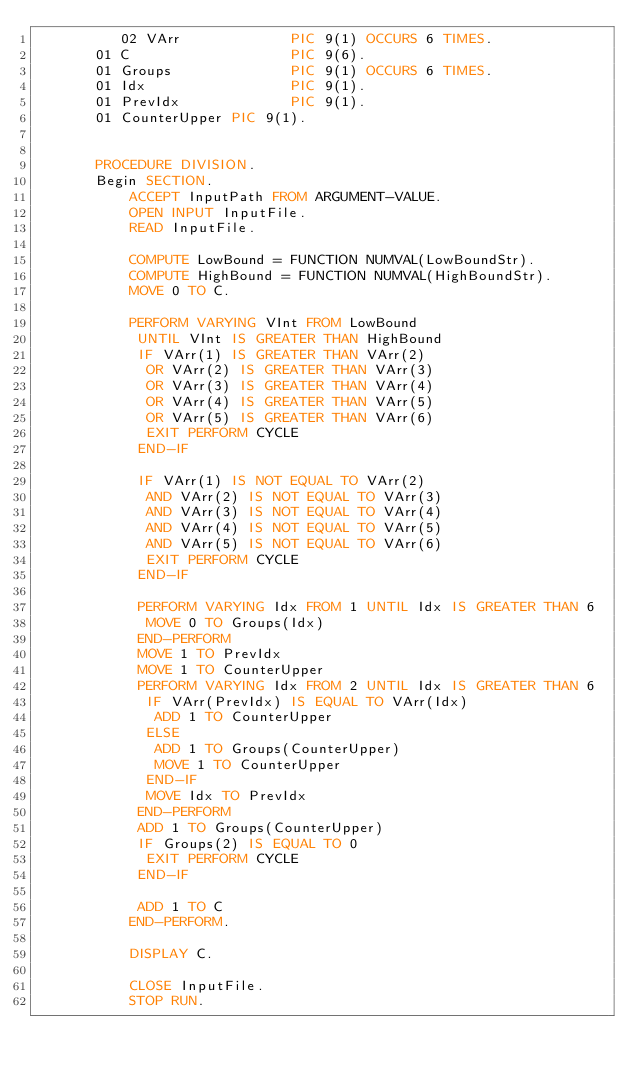<code> <loc_0><loc_0><loc_500><loc_500><_COBOL_>          02 VArr             PIC 9(1) OCCURS 6 TIMES.
       01 C                   PIC 9(6).
       01 Groups              PIC 9(1) OCCURS 6 TIMES.
       01 Idx                 PIC 9(1).
       01 PrevIdx             PIC 9(1).
       01 CounterUpper PIC 9(1).


       PROCEDURE DIVISION.
       Begin SECTION.
           ACCEPT InputPath FROM ARGUMENT-VALUE.
           OPEN INPUT InputFile.
           READ InputFile.

           COMPUTE LowBound = FUNCTION NUMVAL(LowBoundStr).
           COMPUTE HighBound = FUNCTION NUMVAL(HighBoundStr).
           MOVE 0 TO C.

           PERFORM VARYING VInt FROM LowBound 
            UNTIL VInt IS GREATER THAN HighBound
            IF VArr(1) IS GREATER THAN VArr(2)
             OR VArr(2) IS GREATER THAN VArr(3)
             OR VArr(3) IS GREATER THAN VArr(4)
             OR VArr(4) IS GREATER THAN VArr(5)
             OR VArr(5) IS GREATER THAN VArr(6)
             EXIT PERFORM CYCLE
            END-IF

            IF VArr(1) IS NOT EQUAL TO VArr(2)
             AND VArr(2) IS NOT EQUAL TO VArr(3)
             AND VArr(3) IS NOT EQUAL TO VArr(4)
             AND VArr(4) IS NOT EQUAL TO VArr(5)
             AND VArr(5) IS NOT EQUAL TO VArr(6)
             EXIT PERFORM CYCLE
            END-IF

            PERFORM VARYING Idx FROM 1 UNTIL Idx IS GREATER THAN 6
             MOVE 0 TO Groups(Idx)
            END-PERFORM
            MOVE 1 TO PrevIdx
            MOVE 1 TO CounterUpper
            PERFORM VARYING Idx FROM 2 UNTIL Idx IS GREATER THAN 6
             IF VArr(PrevIdx) IS EQUAL TO VArr(Idx)
              ADD 1 TO CounterUpper
             ELSE
              ADD 1 TO Groups(CounterUpper)
              MOVE 1 TO CounterUpper
             END-IF
             MOVE Idx TO PrevIdx
            END-PERFORM
            ADD 1 TO Groups(CounterUpper)
            IF Groups(2) IS EQUAL TO 0
             EXIT PERFORM CYCLE
            END-IF

            ADD 1 TO C
           END-PERFORM.

           DISPLAY C.

           CLOSE InputFile.
           STOP RUN.

</code> 